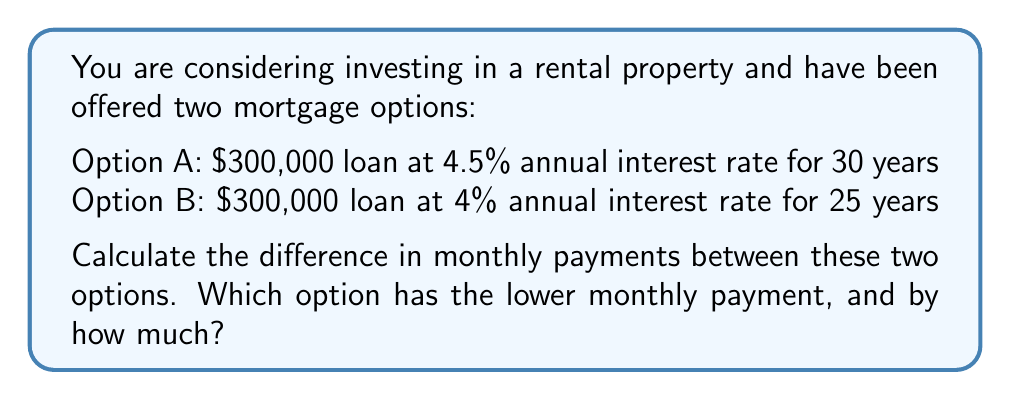Teach me how to tackle this problem. To solve this problem, we'll use the mortgage payment formula:

$$P = L \frac{r(1+r)^n}{(1+r)^n - 1}$$

Where:
$P$ = Monthly payment
$L$ = Loan amount
$r$ = Monthly interest rate (annual rate divided by 12)
$n$ = Total number of months

Step 1: Calculate monthly payment for Option A
$L = 300,000$
$r = 0.045 / 12 = 0.00375$
$n = 30 * 12 = 360$

$$P_A = 300,000 \frac{0.00375(1+0.00375)^{360}}{(1+0.00375)^{360} - 1}$$

$$P_A = 1,520.06$$

Step 2: Calculate monthly payment for Option B
$L = 300,000$
$r = 0.04 / 12 = 0.00333$
$n = 25 * 12 = 300$

$$P_B = 300,000 \frac{0.00333(1+0.00333)^{300}}{(1+0.00333)^{300} - 1}$$

$$P_B = 1,584.07$$

Step 3: Calculate the difference in monthly payments
Difference = $P_B - P_A = 1,584.07 - 1,520.06 = 64.01$

Option A has the lower monthly payment, and it is $64.01 less than Option B.
Answer: Option A; $64.01 lower 